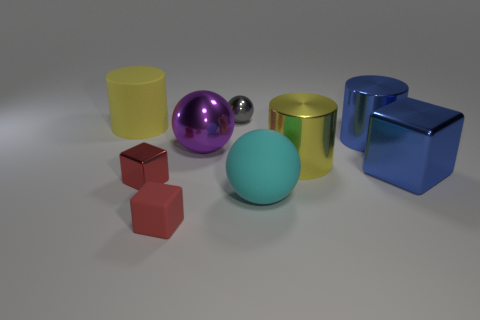There is a object that is behind the yellow thing to the left of the tiny red matte block; is there a object that is in front of it?
Provide a succinct answer. Yes. How many other things are the same size as the matte block?
Provide a short and direct response. 2. There is a tiny rubber cube; are there any matte objects left of it?
Offer a very short reply. Yes. There is a small metal ball; is it the same color as the rubber block that is in front of the big yellow shiny cylinder?
Offer a very short reply. No. There is a rubber thing on the right side of the big ball behind the yellow cylinder right of the tiny red shiny thing; what is its color?
Your answer should be compact. Cyan. Are there any other tiny things of the same shape as the yellow metal object?
Provide a short and direct response. No. There is a metal object that is the same size as the gray ball; what color is it?
Your answer should be very brief. Red. What material is the big yellow thing that is behind the big purple ball?
Make the answer very short. Rubber. There is a large matte object right of the large yellow matte cylinder; is it the same shape as the big matte object that is behind the rubber ball?
Keep it short and to the point. No. Are there an equal number of cylinders right of the big cyan thing and small red metallic cylinders?
Provide a succinct answer. No. 